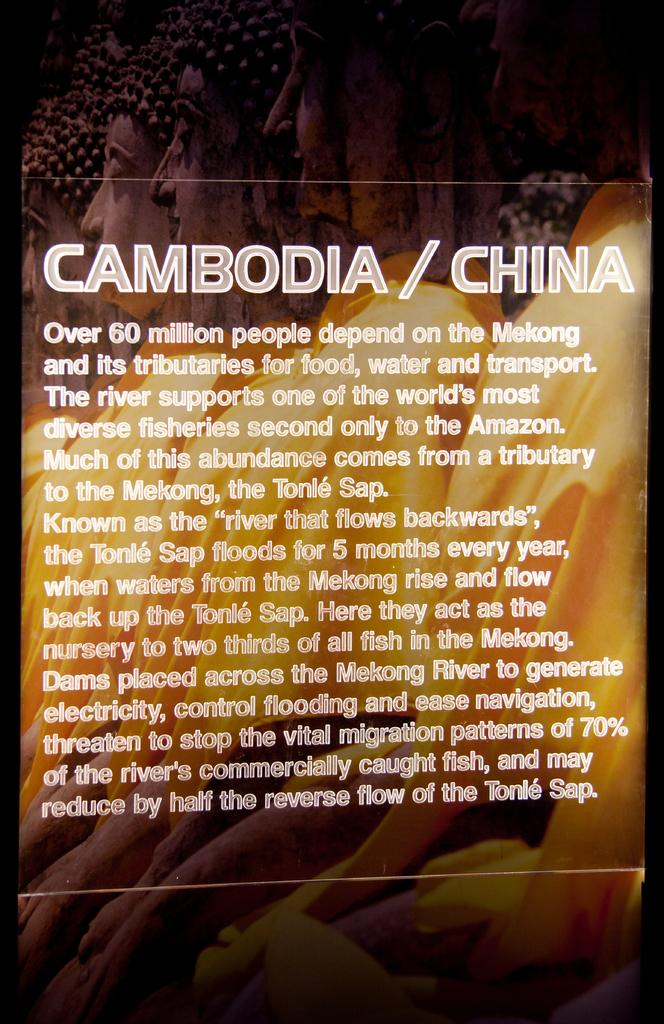<image>
Write a terse but informative summary of the picture. A description for how something relates to Cambodia and China. 